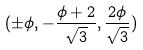Convert formula to latex. <formula><loc_0><loc_0><loc_500><loc_500>( \pm \phi , - \frac { \phi + 2 } { \sqrt { 3 } } , \frac { 2 \phi } { \sqrt { 3 } } )</formula> 